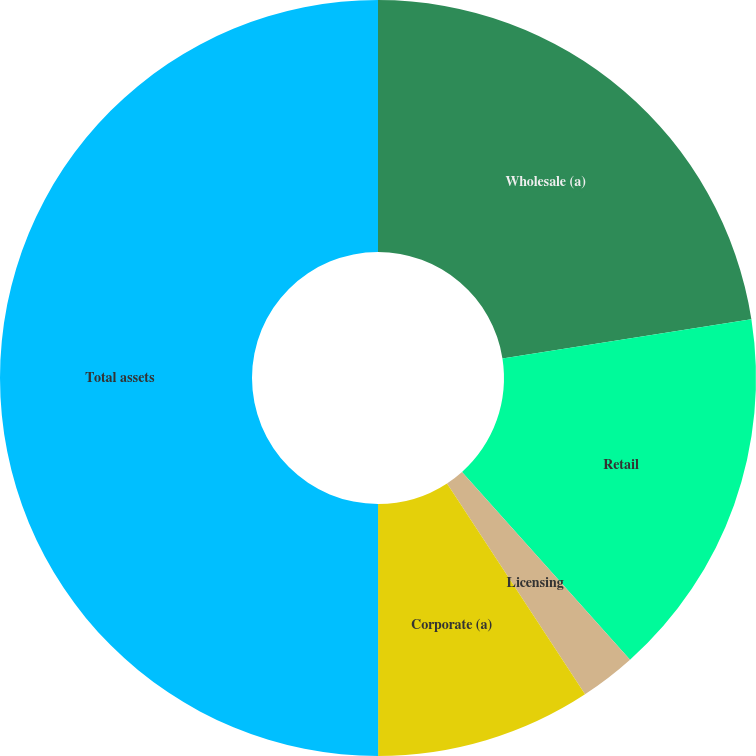Convert chart. <chart><loc_0><loc_0><loc_500><loc_500><pie_chart><fcel>Wholesale (a)<fcel>Retail<fcel>Licensing<fcel>Corporate (a)<fcel>Total assets<nl><fcel>22.51%<fcel>15.87%<fcel>2.39%<fcel>9.22%<fcel>50.0%<nl></chart> 